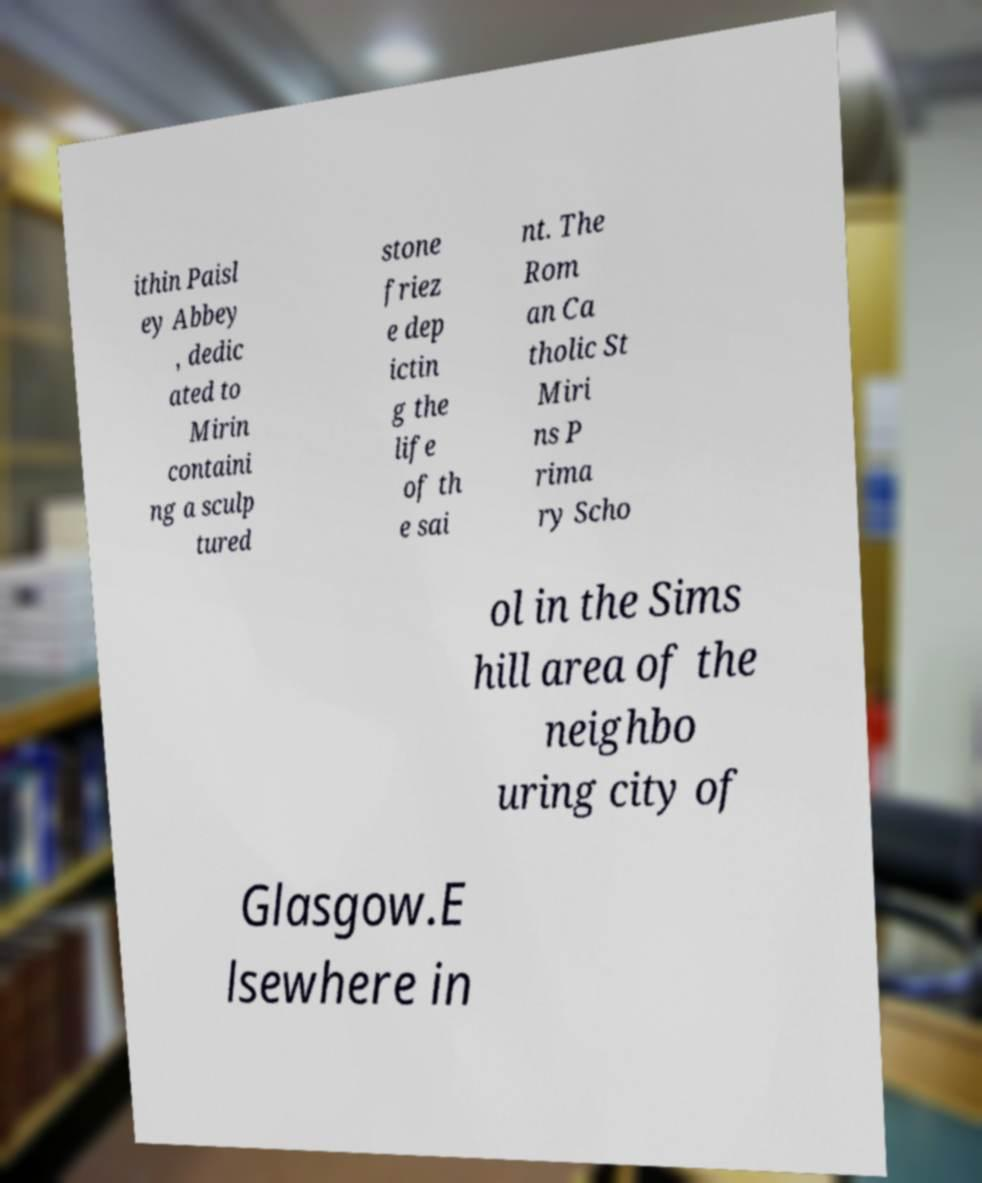Can you accurately transcribe the text from the provided image for me? ithin Paisl ey Abbey , dedic ated to Mirin containi ng a sculp tured stone friez e dep ictin g the life of th e sai nt. The Rom an Ca tholic St Miri ns P rima ry Scho ol in the Sims hill area of the neighbo uring city of Glasgow.E lsewhere in 